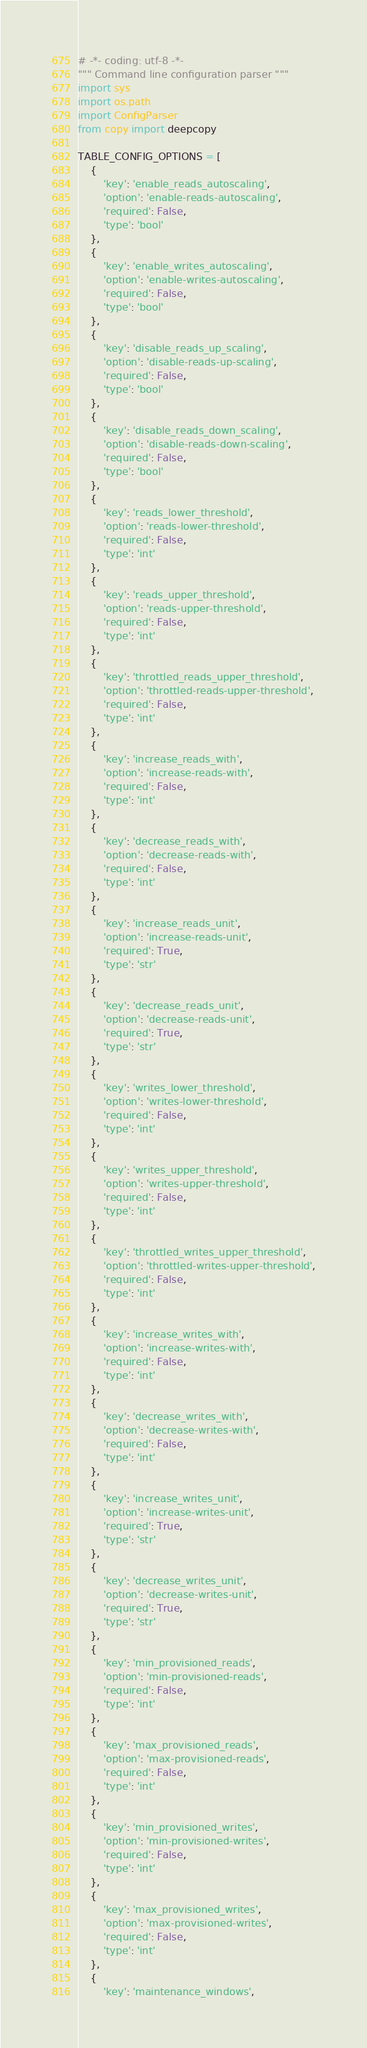<code> <loc_0><loc_0><loc_500><loc_500><_Python_># -*- coding: utf-8 -*-
""" Command line configuration parser """
import sys
import os.path
import ConfigParser
from copy import deepcopy

TABLE_CONFIG_OPTIONS = [
    {
        'key': 'enable_reads_autoscaling',
        'option': 'enable-reads-autoscaling',
        'required': False,
        'type': 'bool'
    },
    {
        'key': 'enable_writes_autoscaling',
        'option': 'enable-writes-autoscaling',
        'required': False,
        'type': 'bool'
    },
    {
        'key': 'disable_reads_up_scaling',
        'option': 'disable-reads-up-scaling',
        'required': False,
        'type': 'bool'
    },
    {
        'key': 'disable_reads_down_scaling',
        'option': 'disable-reads-down-scaling',
        'required': False,
        'type': 'bool'
    },
    {
        'key': 'reads_lower_threshold',
        'option': 'reads-lower-threshold',
        'required': False,
        'type': 'int'
    },
    {
        'key': 'reads_upper_threshold',
        'option': 'reads-upper-threshold',
        'required': False,
        'type': 'int'
    },
    {
        'key': 'throttled_reads_upper_threshold',
        'option': 'throttled-reads-upper-threshold',
        'required': False,
        'type': 'int'
    },
    {
        'key': 'increase_reads_with',
        'option': 'increase-reads-with',
        'required': False,
        'type': 'int'
    },
    {
        'key': 'decrease_reads_with',
        'option': 'decrease-reads-with',
        'required': False,
        'type': 'int'
    },
    {
        'key': 'increase_reads_unit',
        'option': 'increase-reads-unit',
        'required': True,
        'type': 'str'
    },
    {
        'key': 'decrease_reads_unit',
        'option': 'decrease-reads-unit',
        'required': True,
        'type': 'str'
    },
    {
        'key': 'writes_lower_threshold',
        'option': 'writes-lower-threshold',
        'required': False,
        'type': 'int'
    },
    {
        'key': 'writes_upper_threshold',
        'option': 'writes-upper-threshold',
        'required': False,
        'type': 'int'
    },
    {
        'key': 'throttled_writes_upper_threshold',
        'option': 'throttled-writes-upper-threshold',
        'required': False,
        'type': 'int'
    },
    {
        'key': 'increase_writes_with',
        'option': 'increase-writes-with',
        'required': False,
        'type': 'int'
    },
    {
        'key': 'decrease_writes_with',
        'option': 'decrease-writes-with',
        'required': False,
        'type': 'int'
    },
    {
        'key': 'increase_writes_unit',
        'option': 'increase-writes-unit',
        'required': True,
        'type': 'str'
    },
    {
        'key': 'decrease_writes_unit',
        'option': 'decrease-writes-unit',
        'required': True,
        'type': 'str'
    },
    {
        'key': 'min_provisioned_reads',
        'option': 'min-provisioned-reads',
        'required': False,
        'type': 'int'
    },
    {
        'key': 'max_provisioned_reads',
        'option': 'max-provisioned-reads',
        'required': False,
        'type': 'int'
    },
    {
        'key': 'min_provisioned_writes',
        'option': 'min-provisioned-writes',
        'required': False,
        'type': 'int'
    },
    {
        'key': 'max_provisioned_writes',
        'option': 'max-provisioned-writes',
        'required': False,
        'type': 'int'
    },
    {
        'key': 'maintenance_windows',</code> 